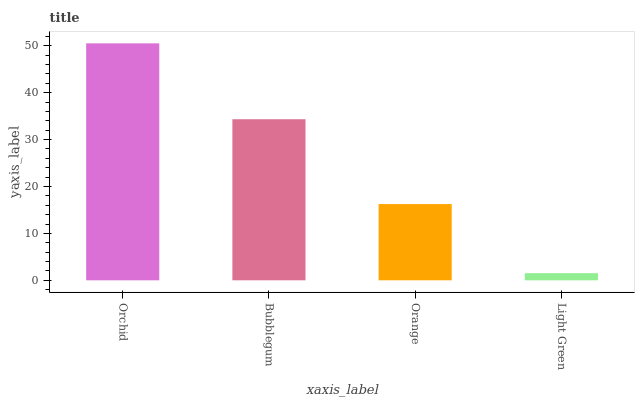Is Light Green the minimum?
Answer yes or no. Yes. Is Orchid the maximum?
Answer yes or no. Yes. Is Bubblegum the minimum?
Answer yes or no. No. Is Bubblegum the maximum?
Answer yes or no. No. Is Orchid greater than Bubblegum?
Answer yes or no. Yes. Is Bubblegum less than Orchid?
Answer yes or no. Yes. Is Bubblegum greater than Orchid?
Answer yes or no. No. Is Orchid less than Bubblegum?
Answer yes or no. No. Is Bubblegum the high median?
Answer yes or no. Yes. Is Orange the low median?
Answer yes or no. Yes. Is Orchid the high median?
Answer yes or no. No. Is Orchid the low median?
Answer yes or no. No. 